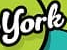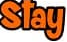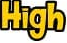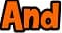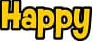What text is displayed in these images sequentially, separated by a semicolon? York; Stay; High; And; Happy 